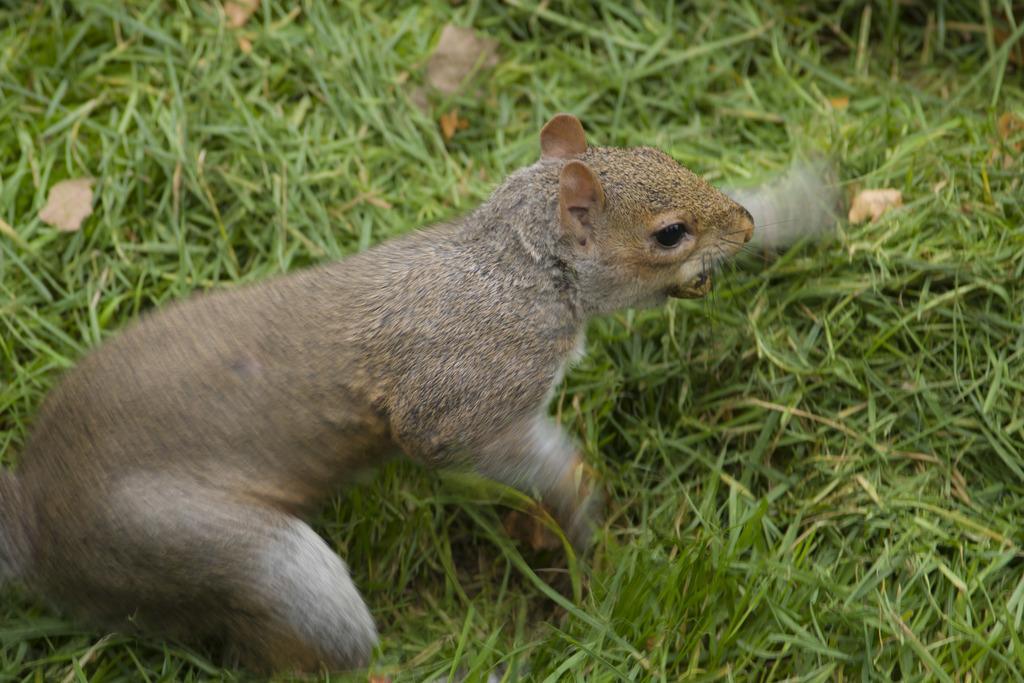Please provide a concise description of this image. In this picture we can see a fox squirrel in the front, at the bottom there is grass. 